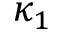<formula> <loc_0><loc_0><loc_500><loc_500>\kappa _ { 1 }</formula> 